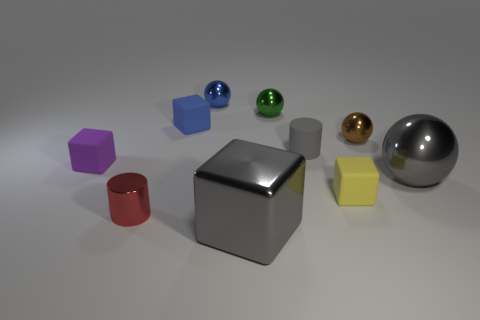Subtract all blue spheres. How many spheres are left? 3 Subtract all balls. How many objects are left? 6 Add 9 green things. How many green things are left? 10 Add 7 gray shiny balls. How many gray shiny balls exist? 8 Subtract all purple blocks. How many blocks are left? 3 Subtract 0 green cylinders. How many objects are left? 10 Subtract 2 cylinders. How many cylinders are left? 0 Subtract all green cubes. Subtract all gray spheres. How many cubes are left? 4 Subtract all yellow cylinders. How many blue cubes are left? 1 Subtract all big blue shiny cylinders. Subtract all brown metallic spheres. How many objects are left? 9 